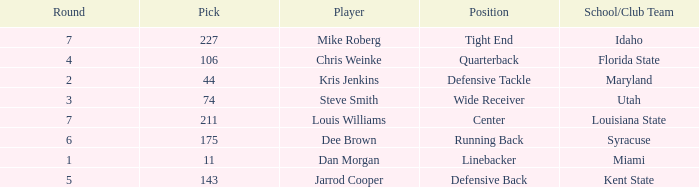Where did steve smith go to school? Utah. 